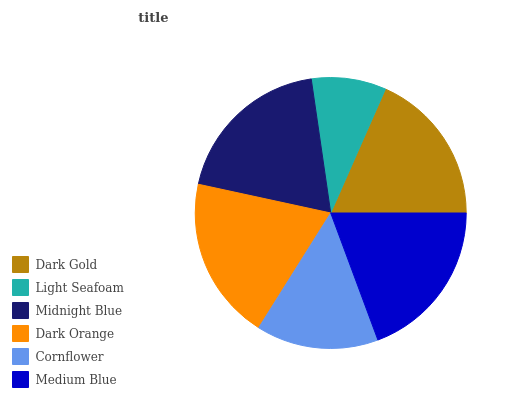Is Light Seafoam the minimum?
Answer yes or no. Yes. Is Dark Orange the maximum?
Answer yes or no. Yes. Is Midnight Blue the minimum?
Answer yes or no. No. Is Midnight Blue the maximum?
Answer yes or no. No. Is Midnight Blue greater than Light Seafoam?
Answer yes or no. Yes. Is Light Seafoam less than Midnight Blue?
Answer yes or no. Yes. Is Light Seafoam greater than Midnight Blue?
Answer yes or no. No. Is Midnight Blue less than Light Seafoam?
Answer yes or no. No. Is Midnight Blue the high median?
Answer yes or no. Yes. Is Dark Gold the low median?
Answer yes or no. Yes. Is Cornflower the high median?
Answer yes or no. No. Is Midnight Blue the low median?
Answer yes or no. No. 